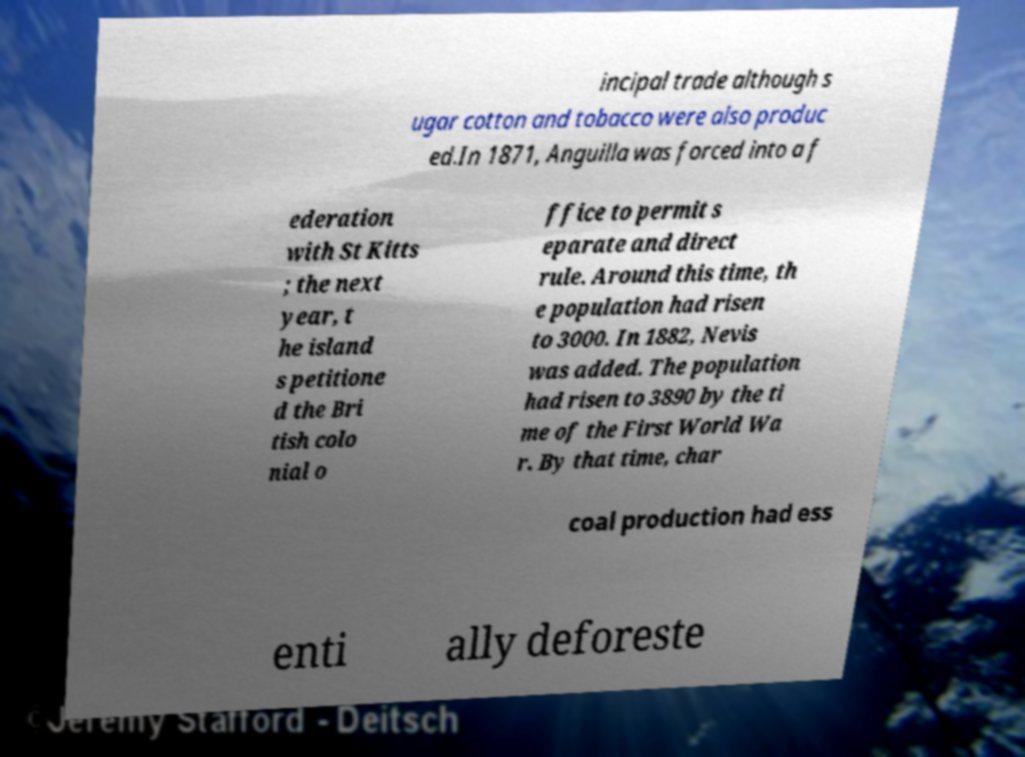Can you read and provide the text displayed in the image?This photo seems to have some interesting text. Can you extract and type it out for me? incipal trade although s ugar cotton and tobacco were also produc ed.In 1871, Anguilla was forced into a f ederation with St Kitts ; the next year, t he island s petitione d the Bri tish colo nial o ffice to permit s eparate and direct rule. Around this time, th e population had risen to 3000. In 1882, Nevis was added. The population had risen to 3890 by the ti me of the First World Wa r. By that time, char coal production had ess enti ally deforeste 